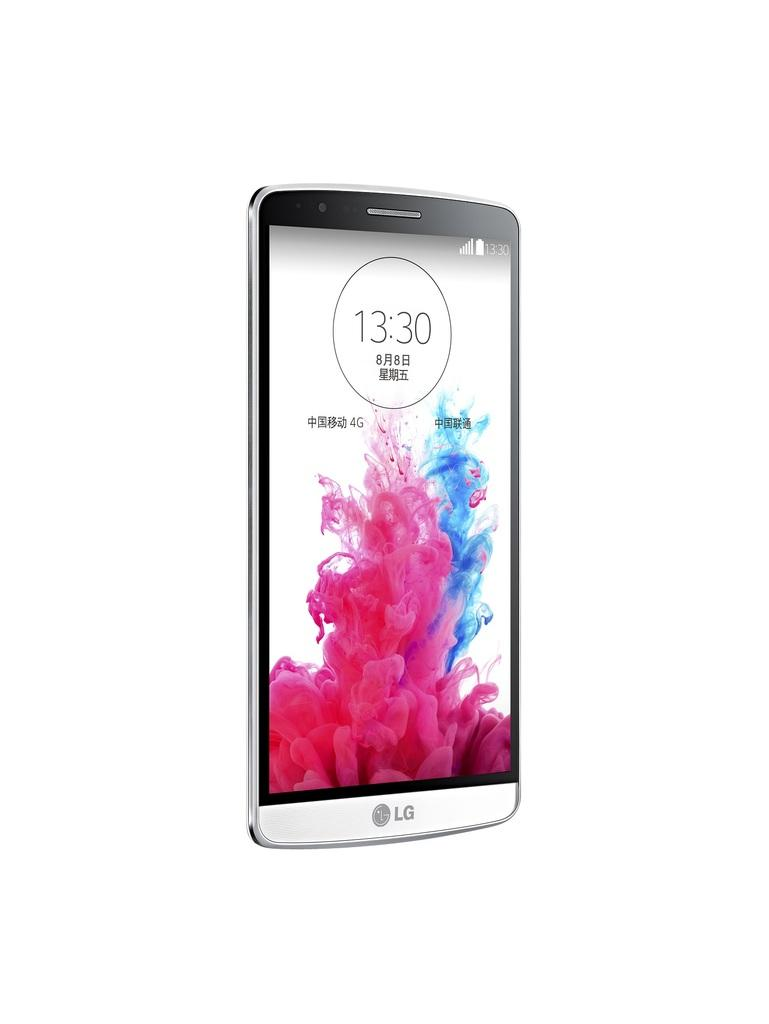<image>
Write a terse but informative summary of the picture. The time on the LG phone is 13:30. 